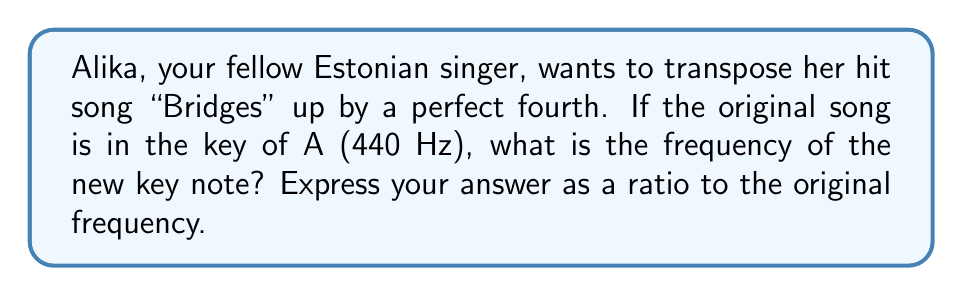Could you help me with this problem? To solve this problem, we need to understand the relationship between musical intervals and frequency ratios:

1. A perfect fourth is an interval of 4 semitones (half steps).
2. In the equal temperament system, each semitone has a frequency ratio of $\sqrt[12]{2}$.
3. To calculate the frequency ratio for a perfect fourth, we raise $\sqrt[12]{2}$ to the power of 4.

Let's calculate step by step:

1. Frequency ratio for one semitone: $\sqrt[12]{2} \approx 1.0594631$
2. Frequency ratio for a perfect fourth: $(\sqrt[12]{2})^4$

We can simplify this expression:

$$(\sqrt[12]{2})^4 = \sqrt[3]{2} \approx 1.2599210$$

This means that the new frequency will be approximately 1.2599210 times the original frequency.

To verify:
Original frequency: 440 Hz
New frequency: $440 \times \sqrt[3]{2} \approx 554.3653 \text{ Hz}$

Indeed, this is the frequency of the note D, which is a perfect fourth above A.
Answer: The frequency ratio between the original key note and the new key note is $\sqrt[3]{2}$ : 1, or approximately 1.2599210 : 1. 